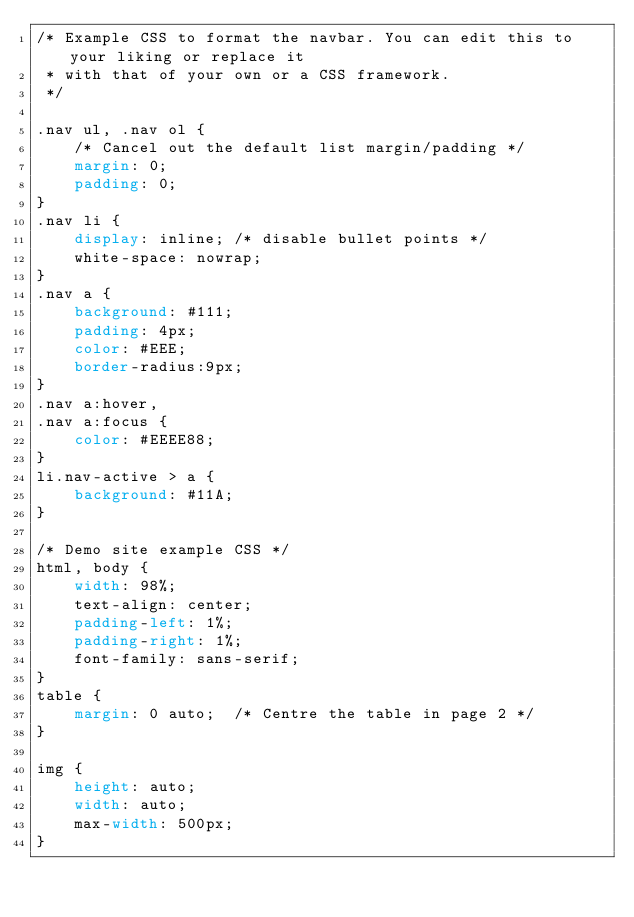<code> <loc_0><loc_0><loc_500><loc_500><_CSS_>/* Example CSS to format the navbar. You can edit this to your liking or replace it
 * with that of your own or a CSS framework.
 */

.nav ul, .nav ol {
    /* Cancel out the default list margin/padding */
    margin: 0;
    padding: 0;
}
.nav li {
    display: inline; /* disable bullet points */
    white-space: nowrap;
}
.nav a {
    background: #111;
    padding: 4px;
    color: #EEE;
    border-radius:9px;
}
.nav a:hover,
.nav a:focus {
    color: #EEEE88;
}
li.nav-active > a {
    background: #11A;
}

/* Demo site example CSS */
html, body {
    width: 98%;
    text-align: center;
    padding-left: 1%;
    padding-right: 1%;
    font-family: sans-serif;
}
table {
    margin: 0 auto;  /* Centre the table in page 2 */
}

img {
    height: auto;
    width: auto;
    max-width: 500px;
}
</code> 